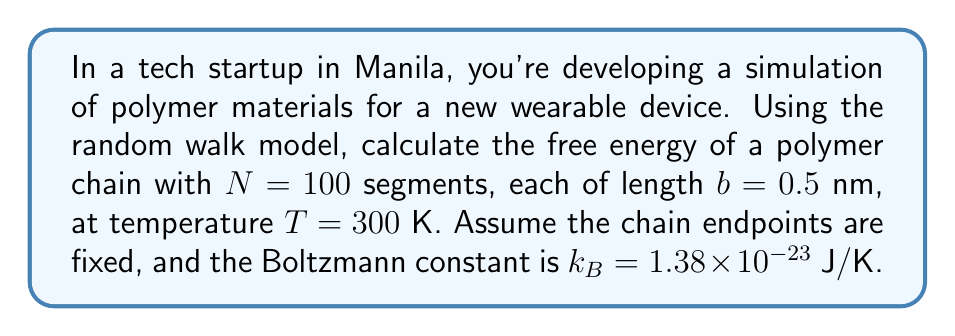What is the answer to this math problem? To evaluate the free energy of a polymer chain using the random walk model, we'll follow these steps:

1) In the random walk model, the end-to-end distance $R$ of a polymer chain follows a Gaussian distribution:

   $$P(R) = \left(\frac{3}{2\pi Nb^2}\right)^{3/2} \exp\left(-\frac{3R^2}{2Nb^2}\right)$$

2) The free energy $F$ is related to the probability distribution by:

   $$F(R) = -k_B T \ln P(R) + F_0$$

   where $F_0$ is a constant.

3) Substituting the expression for $P(R)$ into the free energy equation:

   $$F(R) = -k_B T \ln\left[\left(\frac{3}{2\pi Nb^2}\right)^{3/2} \exp\left(-\frac{3R^2}{2Nb^2}\right)\right] + F_0$$

4) Simplifying:

   $$F(R) = -k_B T \left[-\frac{3R^2}{2Nb^2} - \frac{3}{2}\ln\left(\frac{3}{2\pi Nb^2}\right)\right] + F_0$$

5) Rearranging:

   $$F(R) = \frac{3k_B T R^2}{2Nb^2} + \frac{3k_B T}{2}\ln\left(\frac{3}{2\pi Nb^2}\right) + F_0$$

6) The first term represents the elastic energy of the chain, while the second term is the entropic contribution.

7) Plugging in the values:
   $N = 100$
   $b = 0.5 \times 10^{-9}$ m
   $T = 300$ K
   $k_B = 1.38 \times 10^{-23}$ J/K

8) The free energy as a function of $R$ becomes:

   $$F(R) = 3.312 \times 10^{-18} R^2 - 1.71 \times 10^{-20} + F_0$$

   where $R$ is in meters and $F$ is in Joules.
Answer: $F(R) = 3.312 \times 10^{-18} R^2 - 1.71 \times 10^{-20} + F_0$ J 